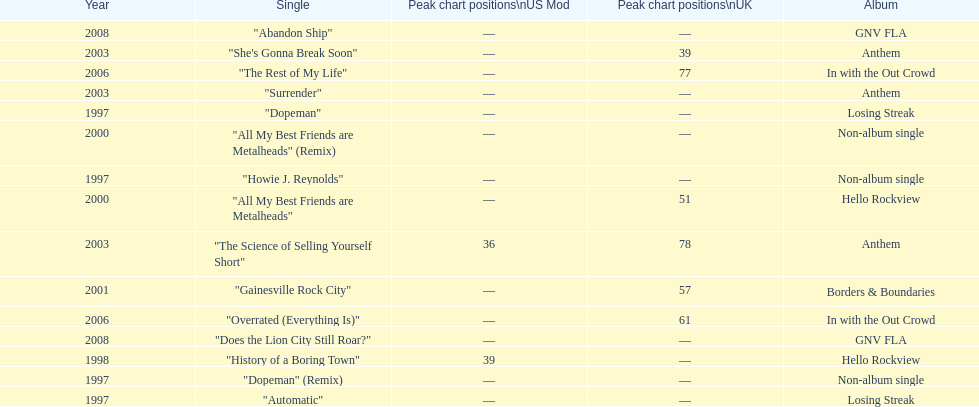What was the average chart position of their singles in the uk? 60.5. 